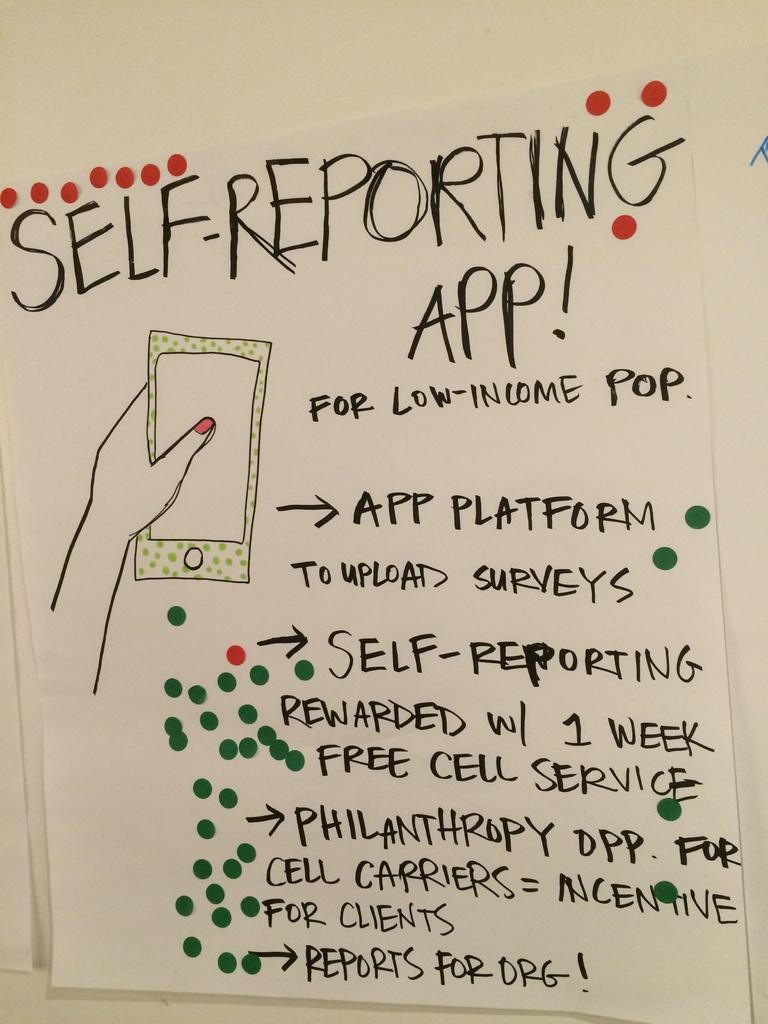What is on the wall in the image? There is a paper pasted on the wall in the image. What is depicted on the paper? The paper contains a picture of a cell phone. Are there any words on the paper? Yes, there is text on the paper. What color is the wall in the image? The wall is white in color. How many hens are sitting on the wall in the image? There are no hens present in the image; it only features a paper with a cell phone picture and text on a white wall. 